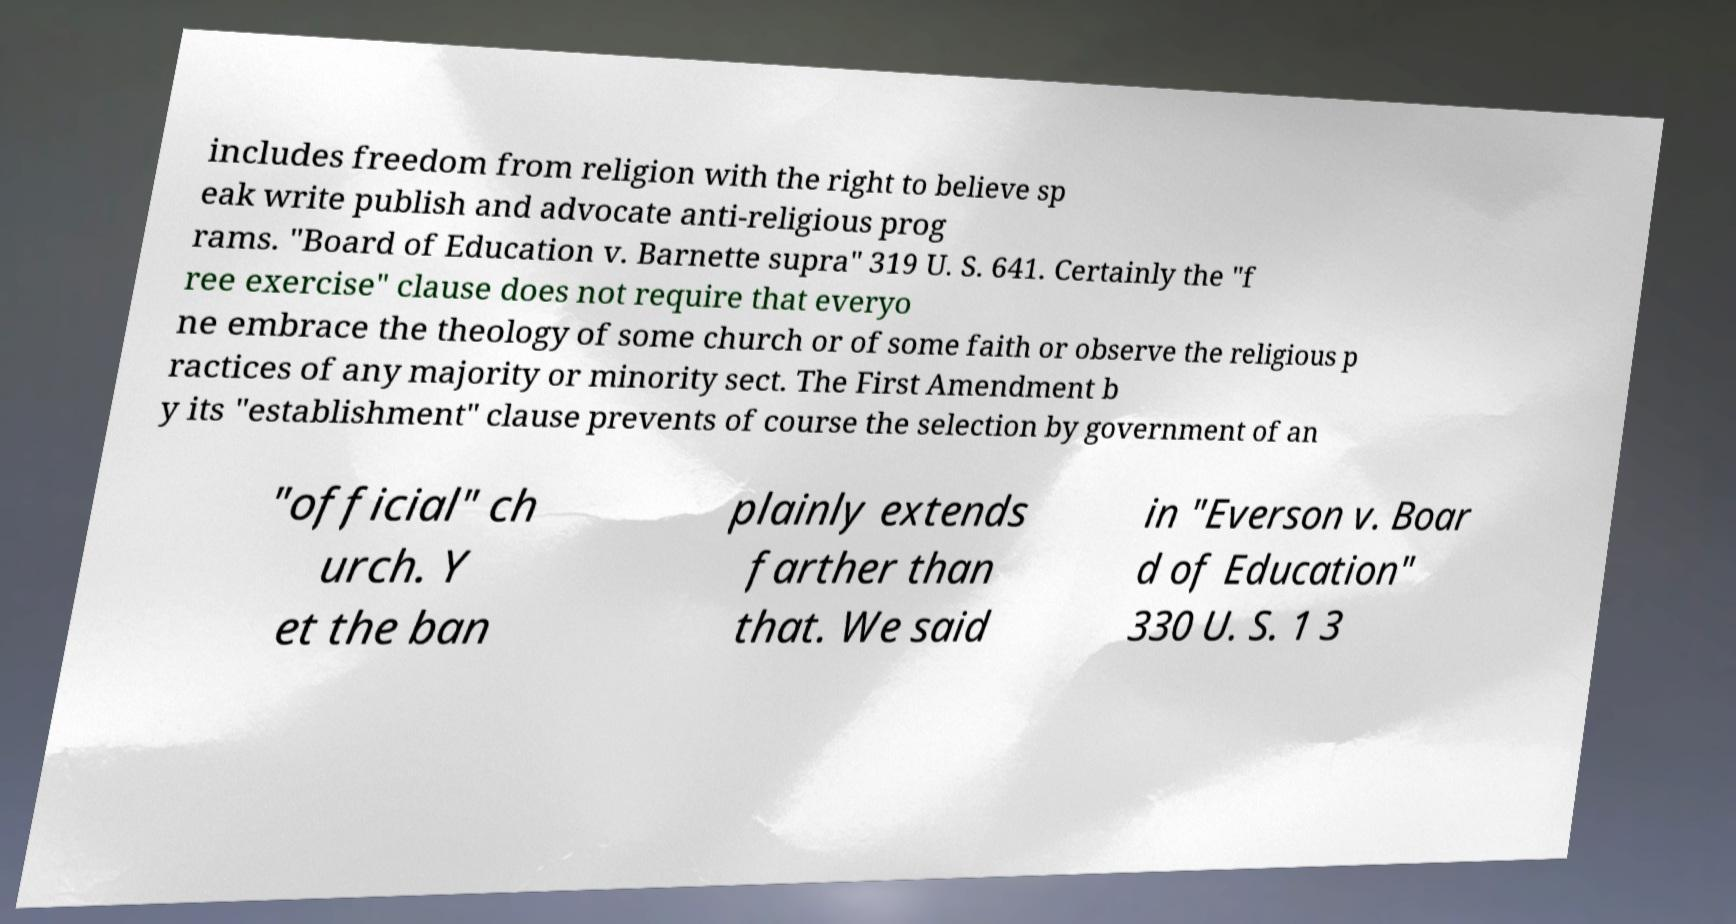There's text embedded in this image that I need extracted. Can you transcribe it verbatim? includes freedom from religion with the right to believe sp eak write publish and advocate anti-religious prog rams. "Board of Education v. Barnette supra" 319 U. S. 641. Certainly the "f ree exercise" clause does not require that everyo ne embrace the theology of some church or of some faith or observe the religious p ractices of any majority or minority sect. The First Amendment b y its "establishment" clause prevents of course the selection by government of an "official" ch urch. Y et the ban plainly extends farther than that. We said in "Everson v. Boar d of Education" 330 U. S. 1 3 